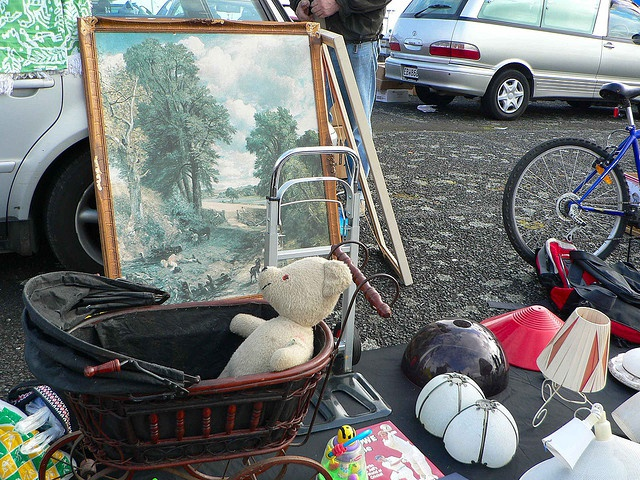Describe the objects in this image and their specific colors. I can see car in lightgreen, black, lightgray, darkgray, and lightblue tones, car in lightgreen, white, lightblue, darkgray, and black tones, bicycle in lightgreen, gray, darkgray, black, and navy tones, teddy bear in lightgreen, darkgray, lightgray, beige, and gray tones, and people in lightgreen, black, gray, and lightblue tones in this image. 